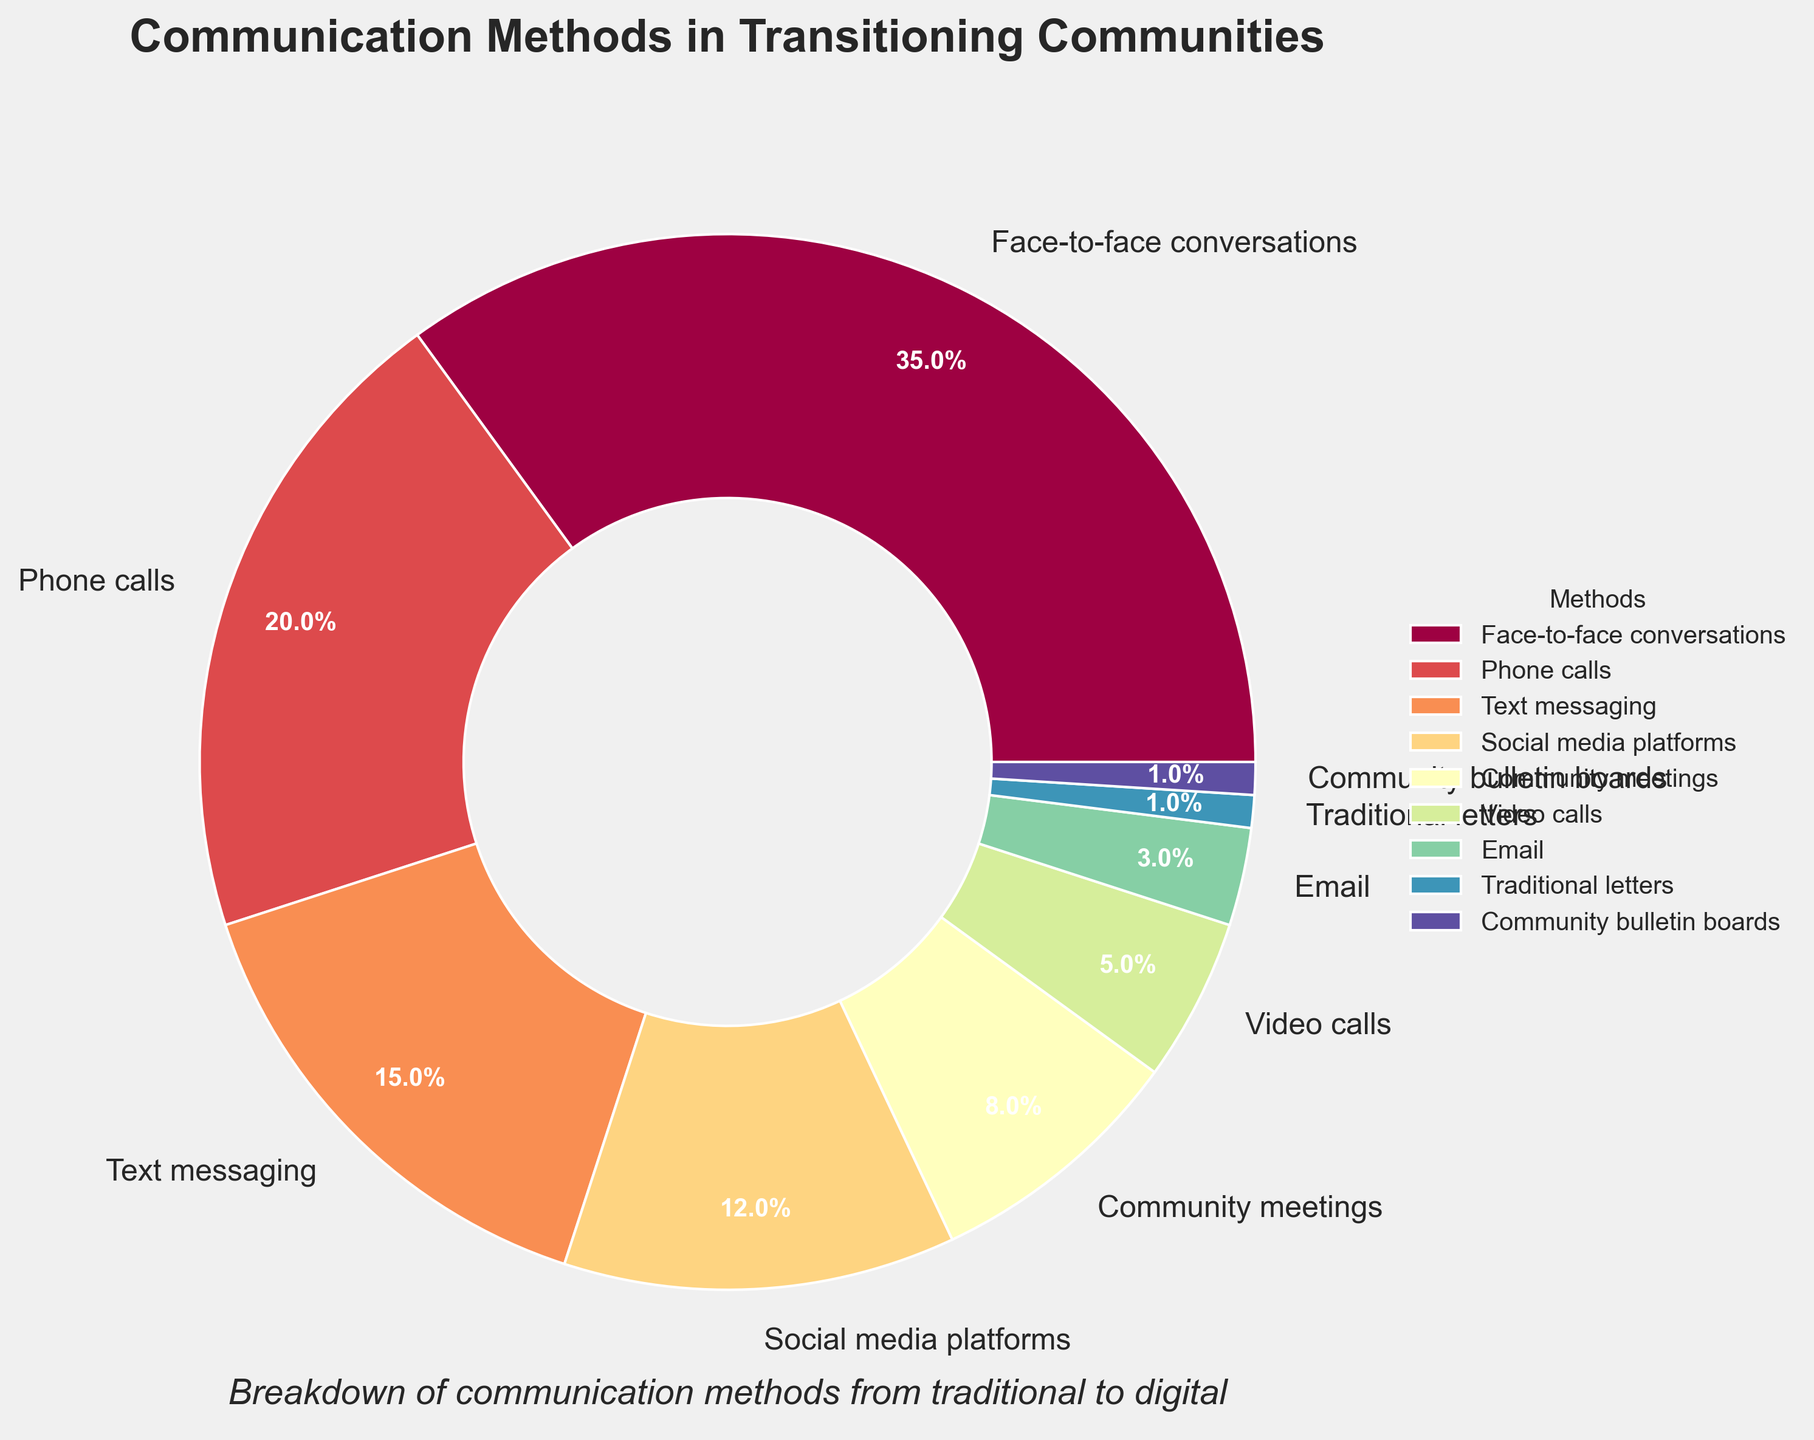What is the most commonly used communication method? The figure shows the breakdown of communication methods by percentage. The slice labeled "Face-to-face conversations" is the largest, with a percentage value of 35%.
Answer: Face-to-face conversations Which communication method is used the least? In the pie chart, "Traditional letters" and "Community bulletin boards" both have the smallest slices, each labeled with 1%.
Answer: Traditional letters and Community bulletin boards How much more popular are phone calls compared to video calls? Phone calls are listed with a percentage of 20%, and video calls are at 5%. The difference is calculated by subtracting 5% (video calls) from 20% (phone calls).
Answer: 15% What is the combined percentage of text messaging and social media platforms? Text messaging is 15% and social media platforms are 12%. Adding these percentages gives 15% + 12% = 27%.
Answer: 27% Which communication methods have a combined usage less than community meetings? Community meetings are 8%. Traditional letters (1%) plus Community bulletin boards (1%) and Email (3%) equal 5%, which is less than 8%.
Answer: Traditional letters, Community bulletin boards, and Email Compare the usage of face-to-face conversations and phone calls to the combined use of text messaging and social media platforms. Face-to-face conversations are 35% and phone calls are 20%, adding to 55%. Text messaging is 15% and social media platforms are 12%, adding to 27%. Thus, 55% is greater than 27%.
Answer: Greater What percentage of communication methods are non-digital (face-to-face conversations, community meetings, traditional letters, community bulletin boards)? Adding the percentages: Face-to-face conversations (35%), Community meetings (8%), Traditional letters (1%), Community bulletin boards (1%) sums up to 35% + 8% + 1% + 1% = 45%.
Answer: 45% Which digital communication method has the highest percentage? Among the digital methods listed, Phone calls have the highest percentage at 20%.
Answer: Phone calls What is the average percentage use of the three least common methods? The three least common methods are Traditional letters (1%), Community bulletin boards (1%), and Email (3%). Their average is (1% + 1% + 3%) / 3 = 1.67%.
Answer: 1.67% Which slice in the chart is visually the smallest, and what could be the significance of this? "Traditional letters" and "Community bulletin boards" are the visually smallest slices, each occupying 1%. Their small size indicates these methods are rarely used compared to others.
Answer: Traditional letters and Community bulletin boards 